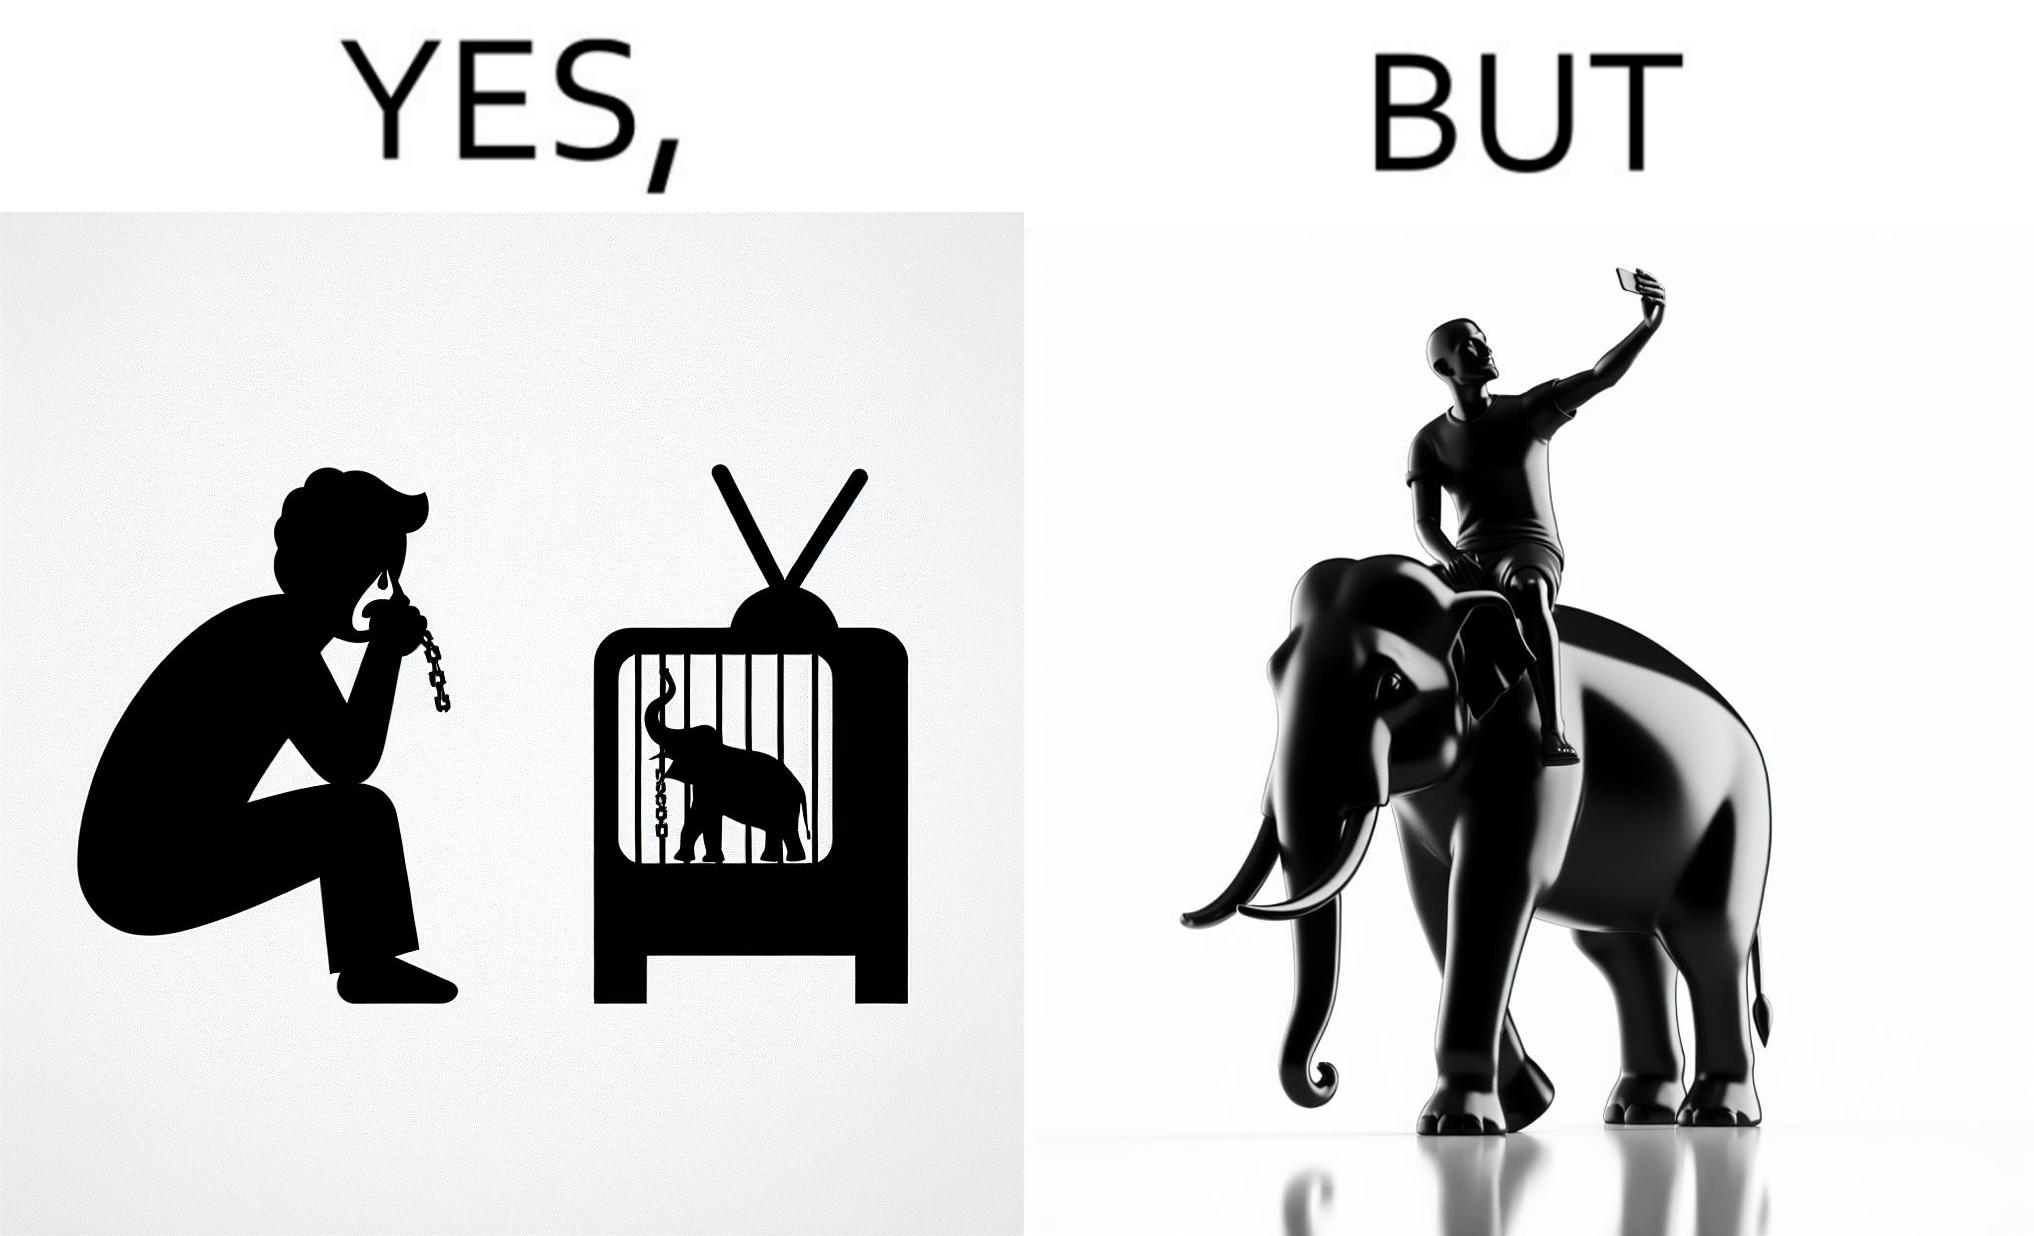Does this image contain satire or humor? Yes, this image is satirical. 